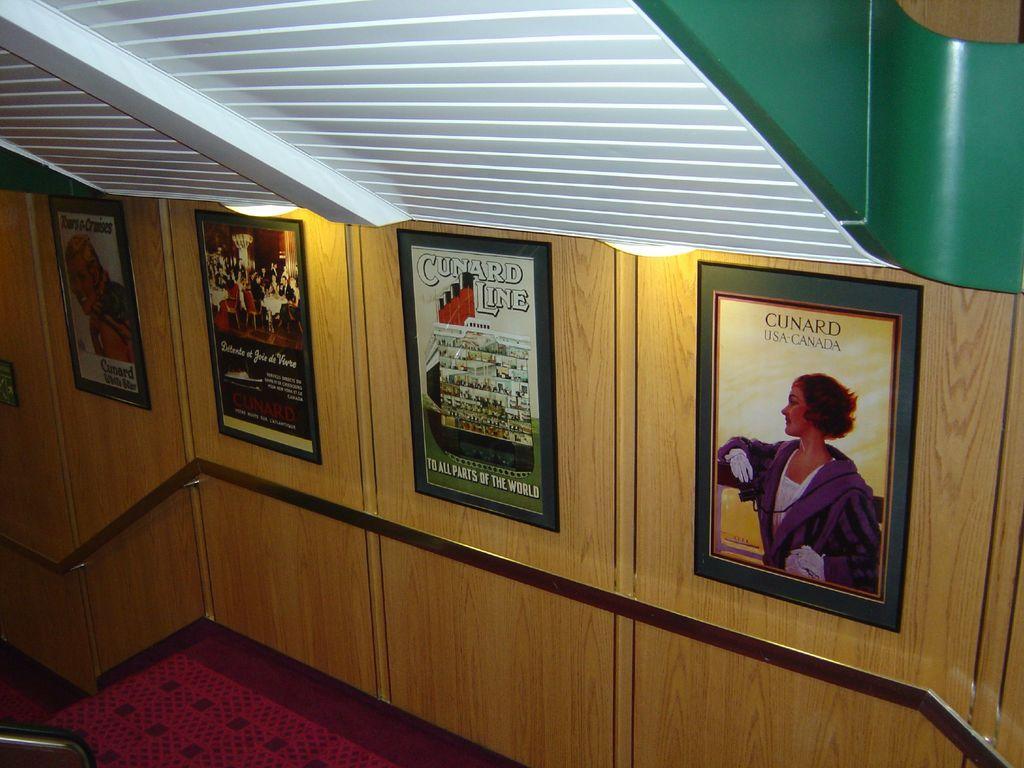Describe this image in one or two sentences. This image looks like it clicked inside the building. At the bottom, we can see a floor mat in red color. In the front, there is a wall on which there are four frames. At the top, there is a roof in white color. On the left, we can see a metal rod. 